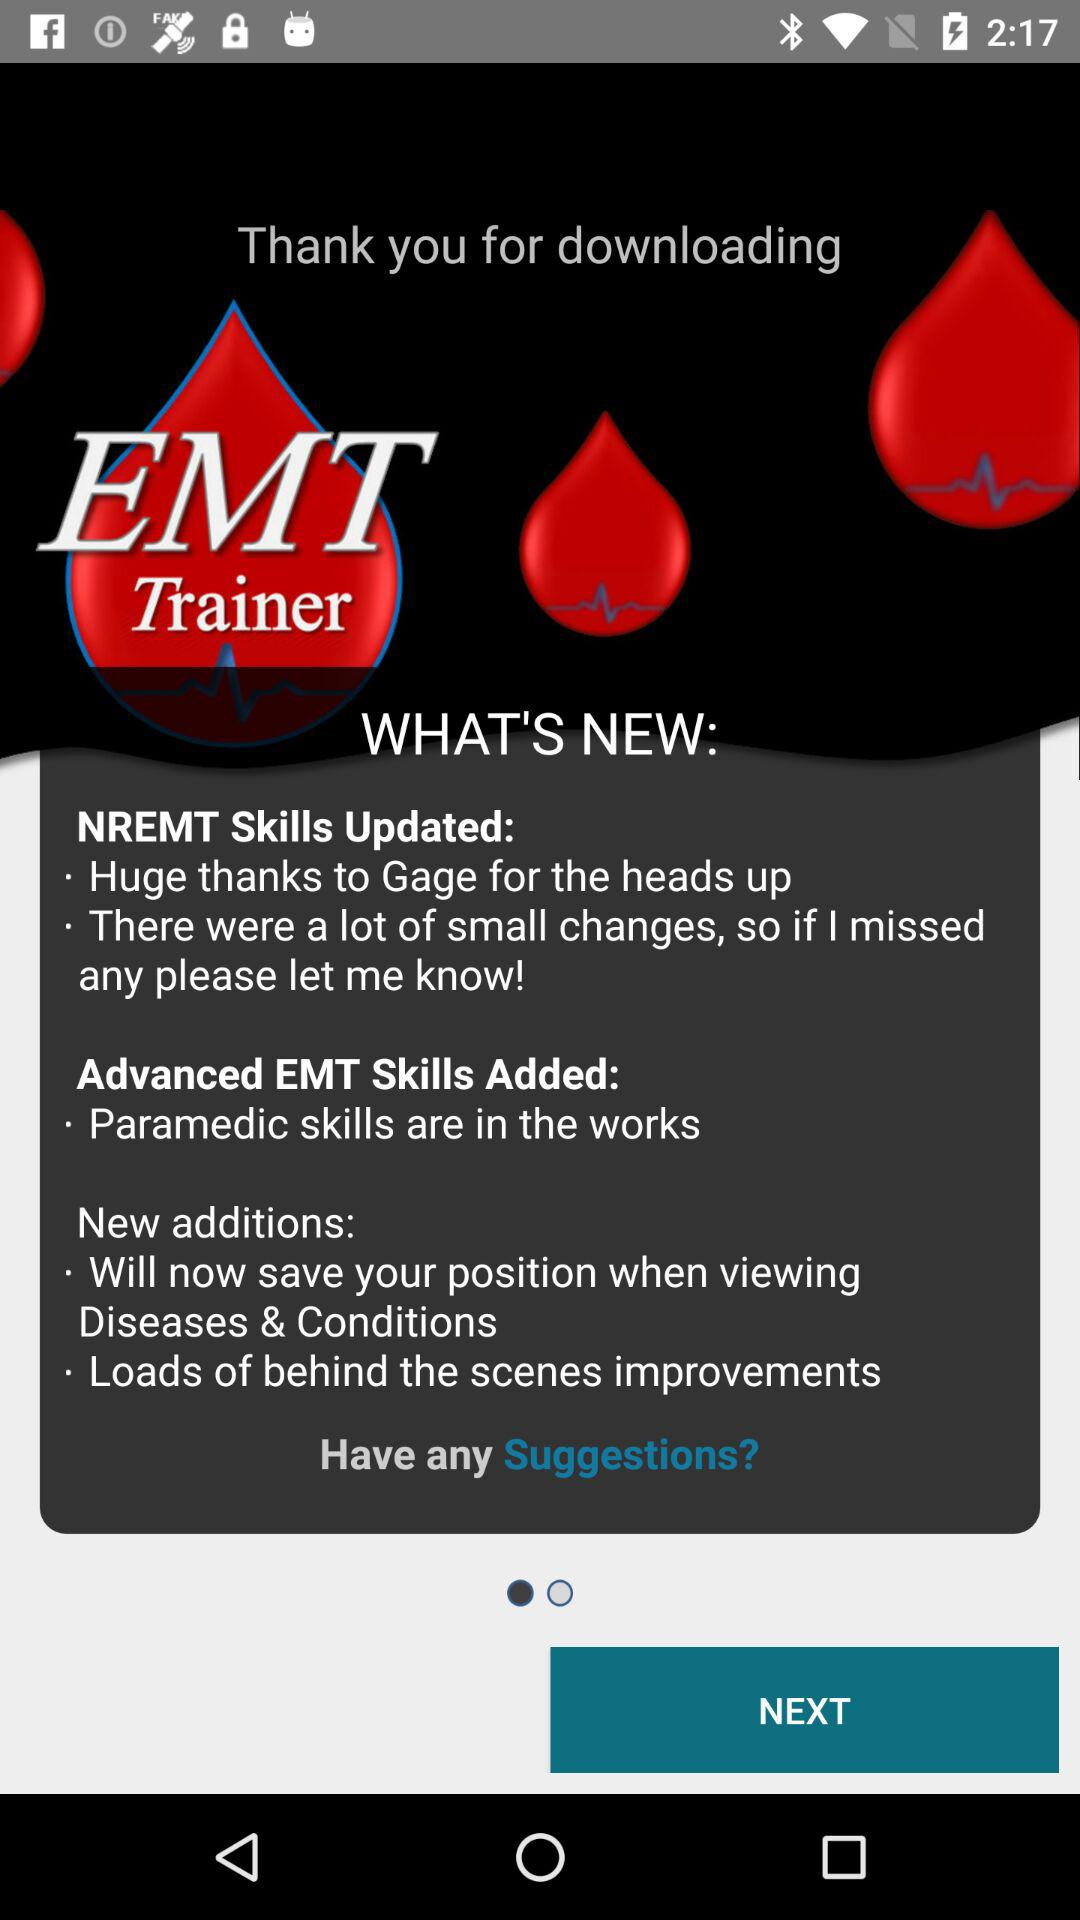How many skills are still in the works?
Answer the question using a single word or phrase. 1 